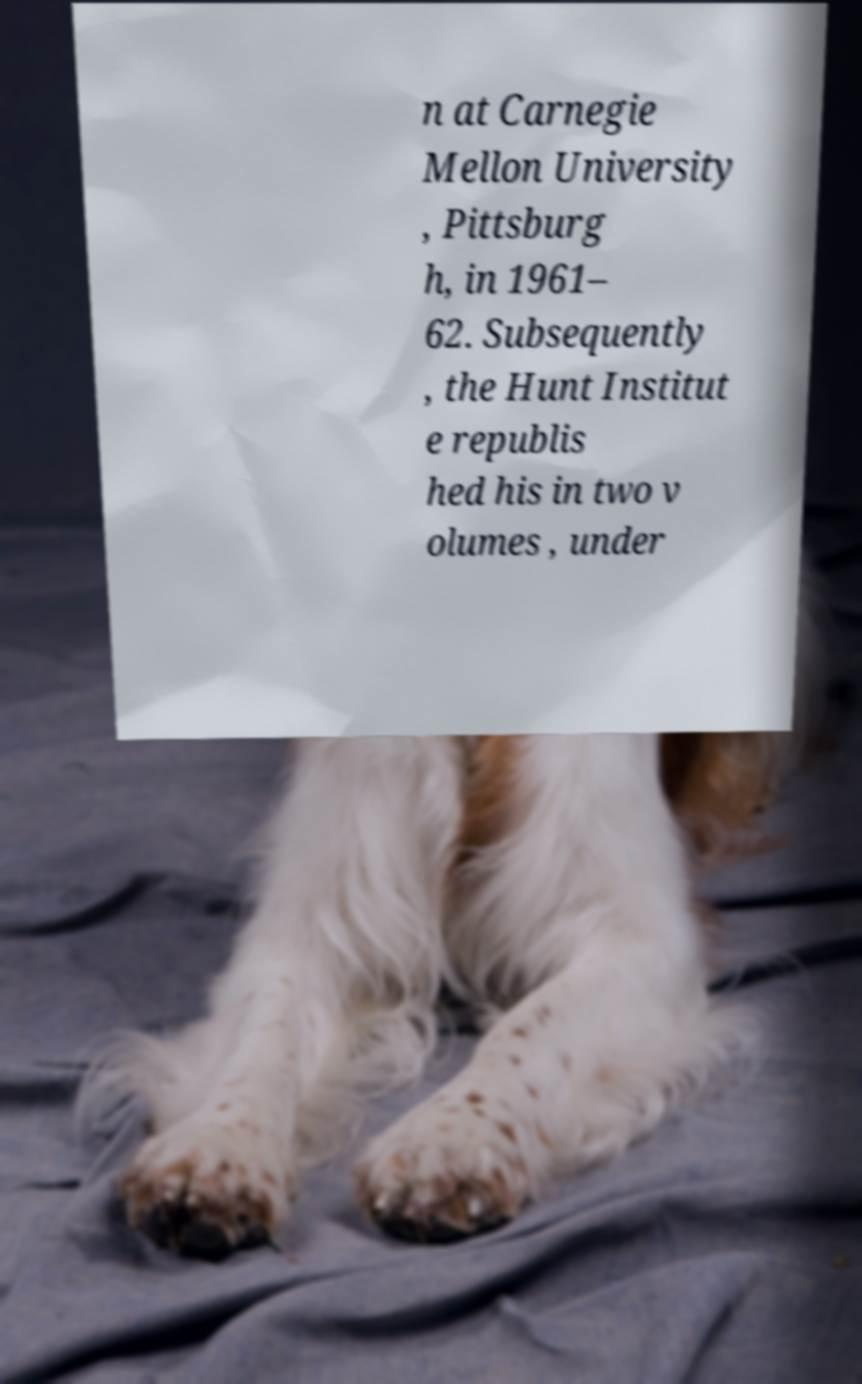What messages or text are displayed in this image? I need them in a readable, typed format. n at Carnegie Mellon University , Pittsburg h, in 1961– 62. Subsequently , the Hunt Institut e republis hed his in two v olumes , under 